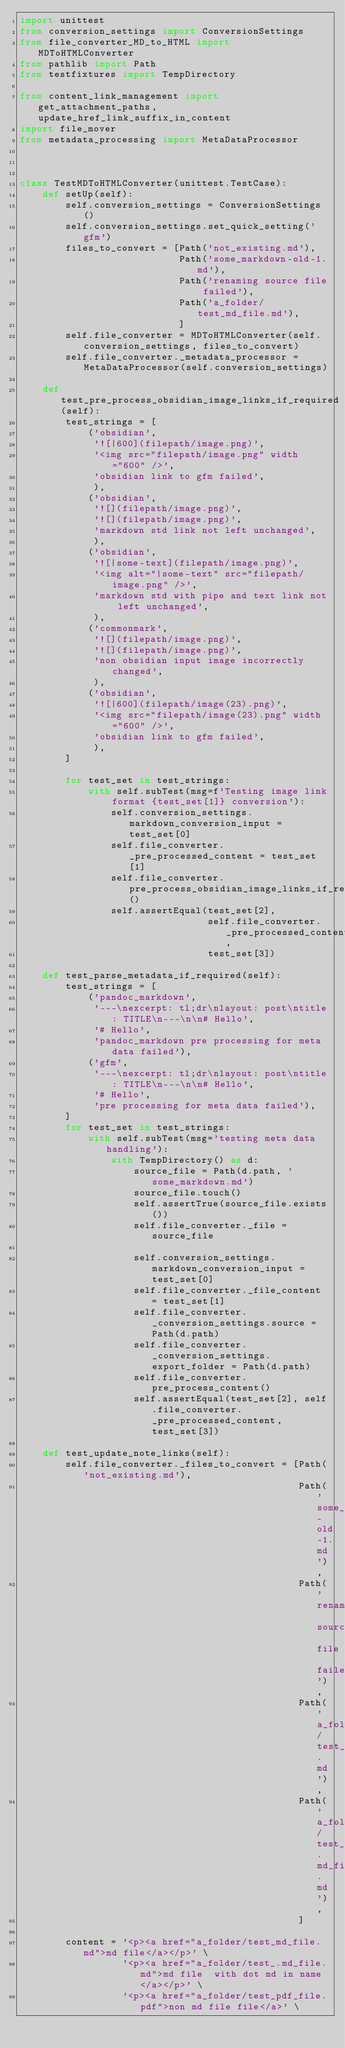<code> <loc_0><loc_0><loc_500><loc_500><_Python_>import unittest
from conversion_settings import ConversionSettings
from file_converter_MD_to_HTML import MDToHTMLConverter
from pathlib import Path
from testfixtures import TempDirectory

from content_link_management import get_attachment_paths, update_href_link_suffix_in_content
import file_mover
from metadata_processing import MetaDataProcessor



class TestMDToHTMLConverter(unittest.TestCase):
    def setUp(self):
        self.conversion_settings = ConversionSettings()
        self.conversion_settings.set_quick_setting('gfm')
        files_to_convert = [Path('not_existing.md'),
                            Path('some_markdown-old-1.md'),
                            Path('renaming source file failed'),
                            Path('a_folder/test_md_file.md'),
                            ]
        self.file_converter = MDToHTMLConverter(self.conversion_settings, files_to_convert)
        self.file_converter._metadata_processor = MetaDataProcessor(self.conversion_settings)

    def test_pre_process_obsidian_image_links_if_required(self):
        test_strings = [
            ('obsidian',
             '![|600](filepath/image.png)',
             '<img src="filepath/image.png" width="600" />',
             'obsidian link to gfm failed',
             ),
            ('obsidian',
             '![](filepath/image.png)',
             '![](filepath/image.png)',
             'markdown std link not left unchanged',
             ),
            ('obsidian',
             '![|some-text](filepath/image.png)',
             '<img alt="|some-text" src="filepath/image.png" />',
             'markdown std with pipe and text link not left unchanged',
             ),
            ('commonmark',
             '![](filepath/image.png)',
             '![](filepath/image.png)',
             'non obsidian input image incorrectly changed',
             ),
            ('obsidian',
             '![|600](filepath/image(23).png)',
             '<img src="filepath/image(23).png" width="600" />',
             'obsidian link to gfm failed',
             ),
        ]

        for test_set in test_strings:
            with self.subTest(msg=f'Testing image link format {test_set[1]} conversion'):
                self.conversion_settings.markdown_conversion_input = test_set[0]
                self.file_converter._pre_processed_content = test_set[1]
                self.file_converter.pre_process_obsidian_image_links_if_required()
                self.assertEqual(test_set[2],
                                 self.file_converter._pre_processed_content,
                                 test_set[3])

    def test_parse_metadata_if_required(self):
        test_strings = [
            ('pandoc_markdown',
             '---\nexcerpt: tl;dr\nlayout: post\ntitle: TITLE\n---\n\n# Hello',
             '# Hello',
             'pandoc_markdown pre processing for meta data failed'),
            ('gfm',
             '---\nexcerpt: tl;dr\nlayout: post\ntitle: TITLE\n---\n\n# Hello',
             '# Hello',
             'pre processing for meta data failed'),
        ]
        for test_set in test_strings:
            with self.subTest(msg='testing meta data handling'):
                with TempDirectory() as d:
                    source_file = Path(d.path, 'some_markdown.md')
                    source_file.touch()
                    self.assertTrue(source_file.exists())
                    self.file_converter._file = source_file

                    self.conversion_settings.markdown_conversion_input = test_set[0]
                    self.file_converter._file_content = test_set[1]
                    self.file_converter._conversion_settings.source = Path(d.path)
                    self.file_converter._conversion_settings.export_folder = Path(d.path)
                    self.file_converter.pre_process_content()
                    self.assertEqual(test_set[2], self.file_converter._pre_processed_content, test_set[3])

    def test_update_note_links(self):
        self.file_converter._files_to_convert = [Path('not_existing.md'),
                                                 Path('some_markdown-old-1.md'),
                                                 Path('renaming source file failed'),
                                                 Path('a_folder/test_md_file.md'),
                                                 Path('a_folder/test_.md_file.md'),
                                                 ]

        content = '<p><a href="a_folder/test_md_file.md">md file</a></p>' \
                  '<p><a href="a_folder/test_.md_file.md">md file  with dot md in name</a></p>' \
                  '<p><a href="a_folder/test_pdf_file.pdf">non md file file</a>' \</code> 